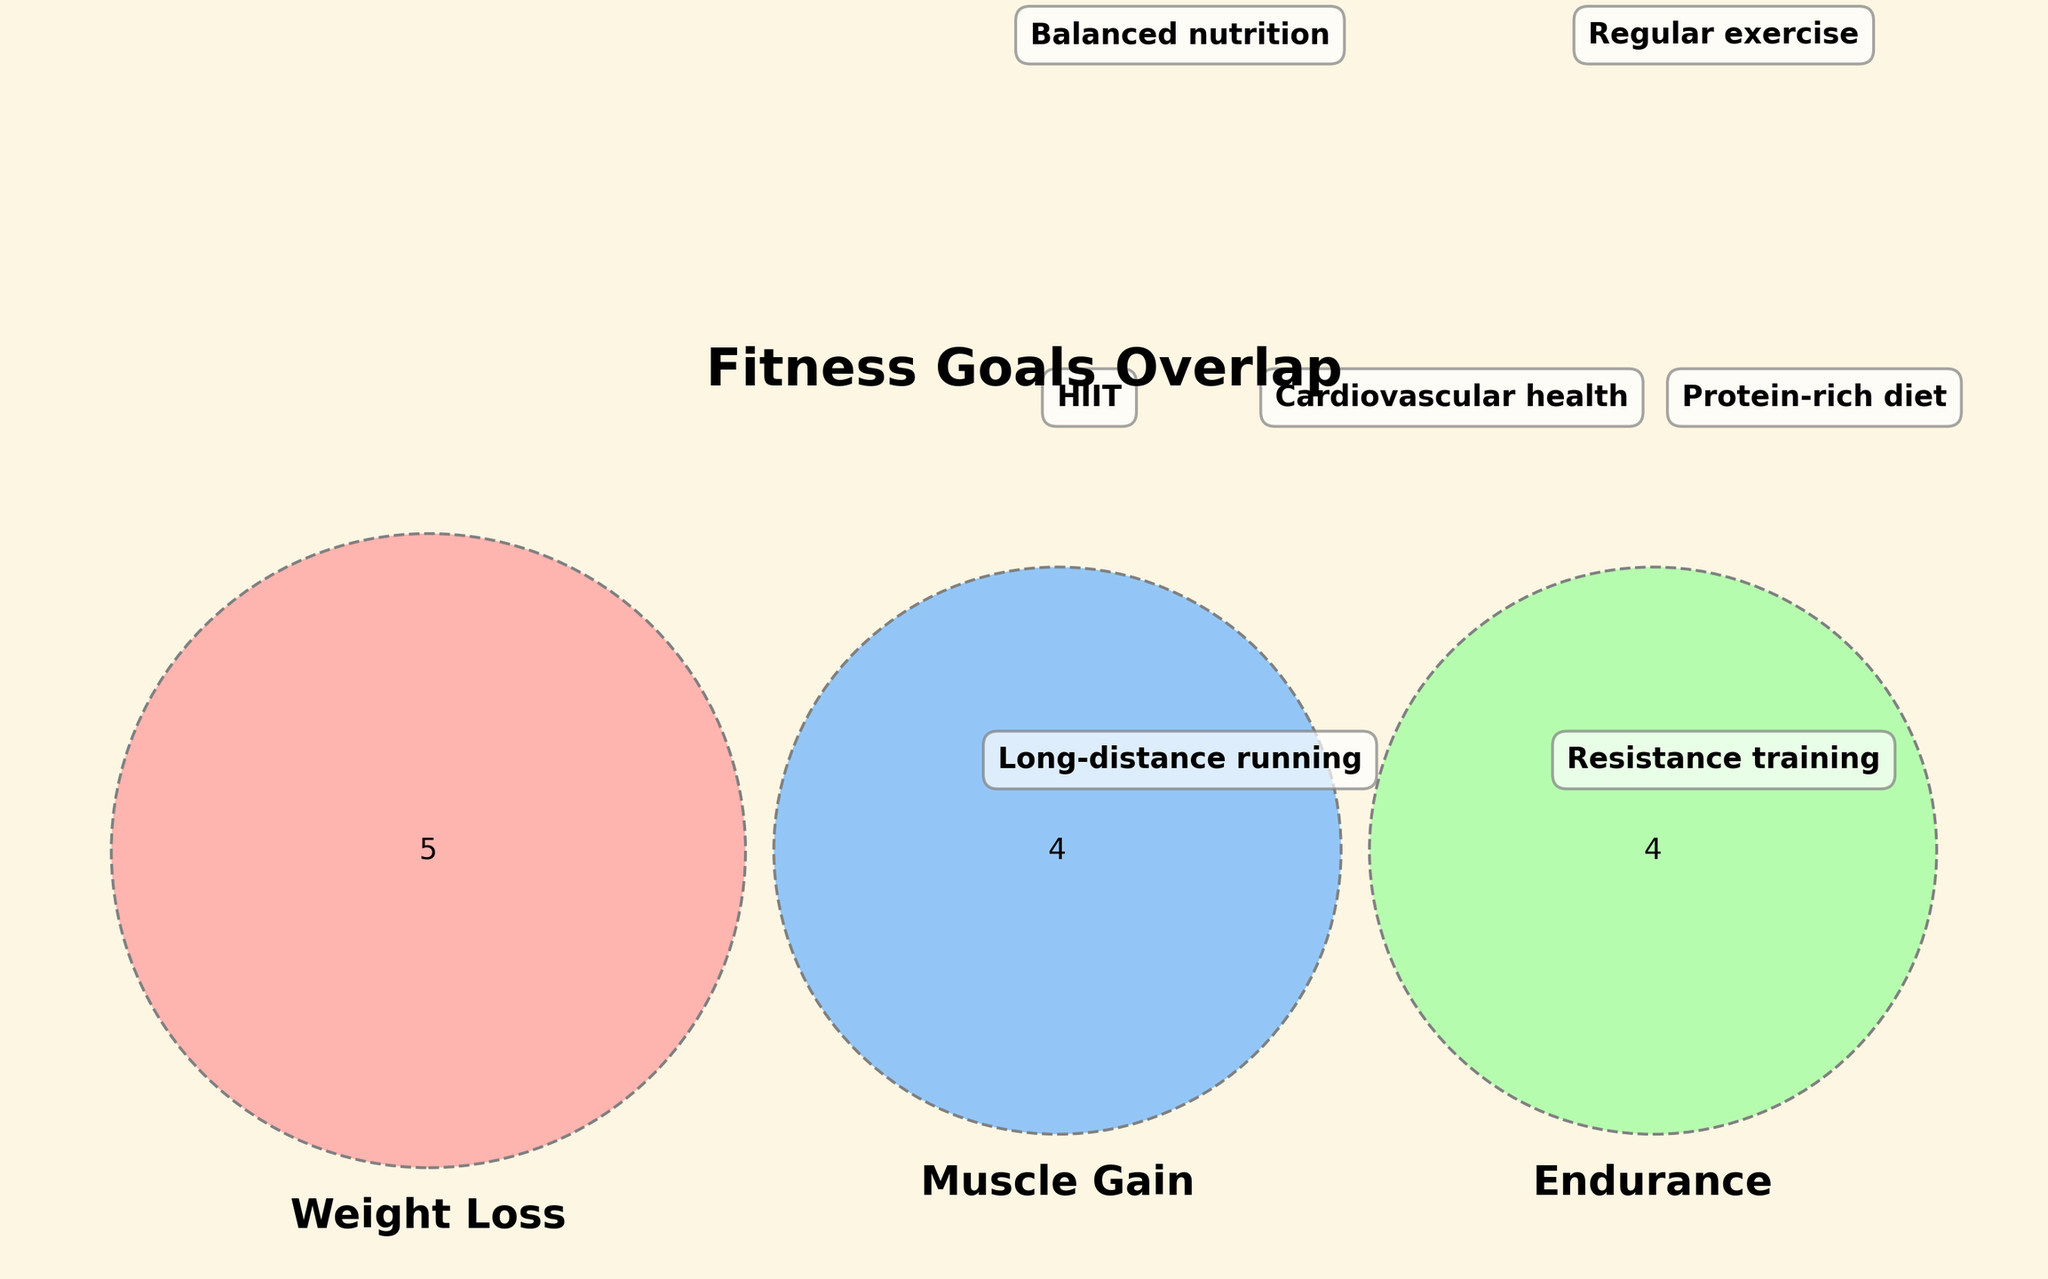What is the title of the Venn diagram? The title is usually displayed at the top of the figure in a larger and bold font. In this case, it reads "Fitness Goals Overlap".
Answer: Fitness Goals Overlap Which fitness goal category has overlaps with both 'Weight Loss' and 'Endurance'? In the Venn diagram, the area where 'Weight Loss' and 'Endurance' overlap shows "Balanced nutrition".
Answer: Balanced nutrition Name a fitness strategy that is unique to 'Weight Loss'. Strategies unique to 'Weight Loss' can be found in the section of the Venn diagram that only intersects with 'Weight Loss'. This includes "Calorie deficit", "HIIT", "Metabolic adaptations", "Intermittent fasting", "Body composition analysis".
Answer: Calorie deficit, HIIT, Metabolic adaptations, Intermittent fasting, Body composition analysis Which fitness goal includes 'Protein-rich diet'? 'Protein-rich diet' is within the section of the Venn diagram that represents 'Muscle Gain'.
Answer: Muscle Gain Which goal-related activity falls under 'Endurance' and not others? Activities under 'Endurance' but not overlapping with other categories can be identified within the 'Endurance' section only. These include "Long-distance running", "Cycling", and "VO2 max improvement".
Answer: Long-distance running, Cycling, VO2 max improvement What activity is shared between all three fitness goals? The activity shared between all three fitness goals is found in the intersection of all three circles. Here, it is labeled "Balanced nutrition".
Answer: Balanced nutrition Compare the number of activities related to 'Muscle Gain' only and 'Weight Loss' only. 'Muscle Gain' uniquely includes "Protein-rich diet", "Progressive overload", "Hypertrophy" and "Resistance training". 'Weight Loss' uniquely includes "Calorie deficit", "HIIT", "Metabolic adaptations", "Intermittent fasting", "Body composition analysis". Counting these, 'Muscle Gain' has 4 activities, while 'Weight Loss' has 5.
Answer: Weight Loss has 1 more Is 'Regular exercise' part of the "Muscle Gain" goals? 'Regular exercise' falls in the section where 'Muscle Gain' and 'Endurance' goals overlap, thus it is not exclusive to "Muscle Gain" but it is still part of it.
Answer: Yes Which category improves 'Cardiovascular health'? 'Cardiovascular health' is shown within the 'Endurance' category on its segment in the Venn diagram.
Answer: Endurance 